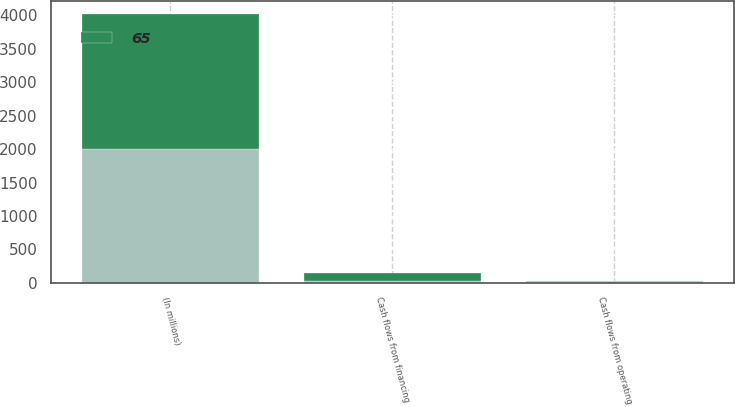Convert chart to OTSL. <chart><loc_0><loc_0><loc_500><loc_500><stacked_bar_chart><ecel><fcel>(In millions)<fcel>Cash flows from operating<fcel>Cash flows from financing<nl><fcel>nan<fcel>2008<fcel>25<fcel>25<nl><fcel>65<fcel>2006<fcel>11<fcel>125<nl></chart> 